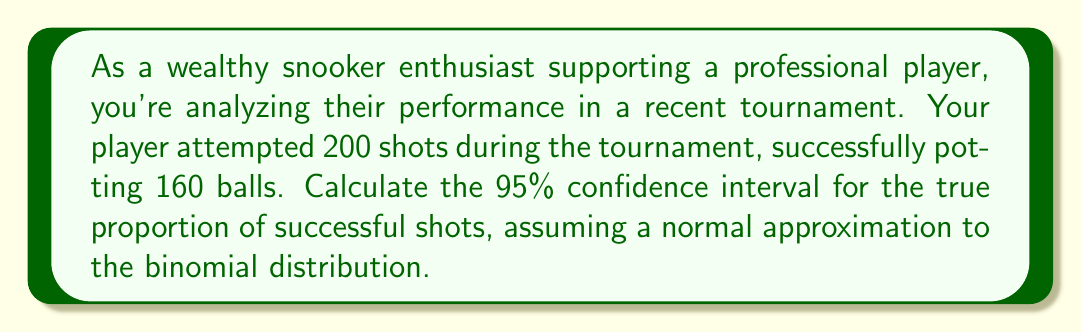Provide a solution to this math problem. Let's approach this step-by-step:

1) First, we calculate the sample proportion $\hat{p}$:
   $$\hat{p} = \frac{\text{Number of successes}}{\text{Total number of trials}} = \frac{160}{200} = 0.8$$

2) The formula for the confidence interval is:
   $$\hat{p} \pm z_{\alpha/2} \sqrt{\frac{\hat{p}(1-\hat{p})}{n}}$$
   where $z_{\alpha/2}$ is the critical value for the desired confidence level, and $n$ is the sample size.

3) For a 95% confidence interval, $z_{\alpha/2} = 1.96$

4) Now, let's calculate the standard error:
   $$SE = \sqrt{\frac{\hat{p}(1-\hat{p})}{n}} = \sqrt{\frac{0.8(1-0.8)}{200}} = \sqrt{\frac{0.16}{200}} = 0.0283$$

5) The margin of error is:
   $$ME = z_{\alpha/2} \cdot SE = 1.96 \cdot 0.0283 = 0.0554$$

6) Therefore, the confidence interval is:
   $$0.8 \pm 0.0554$$

7) This gives us the interval:
   $$(0.8 - 0.0554, 0.8 + 0.0554) = (0.7446, 0.8554)$$
Answer: (0.7446, 0.8554) 